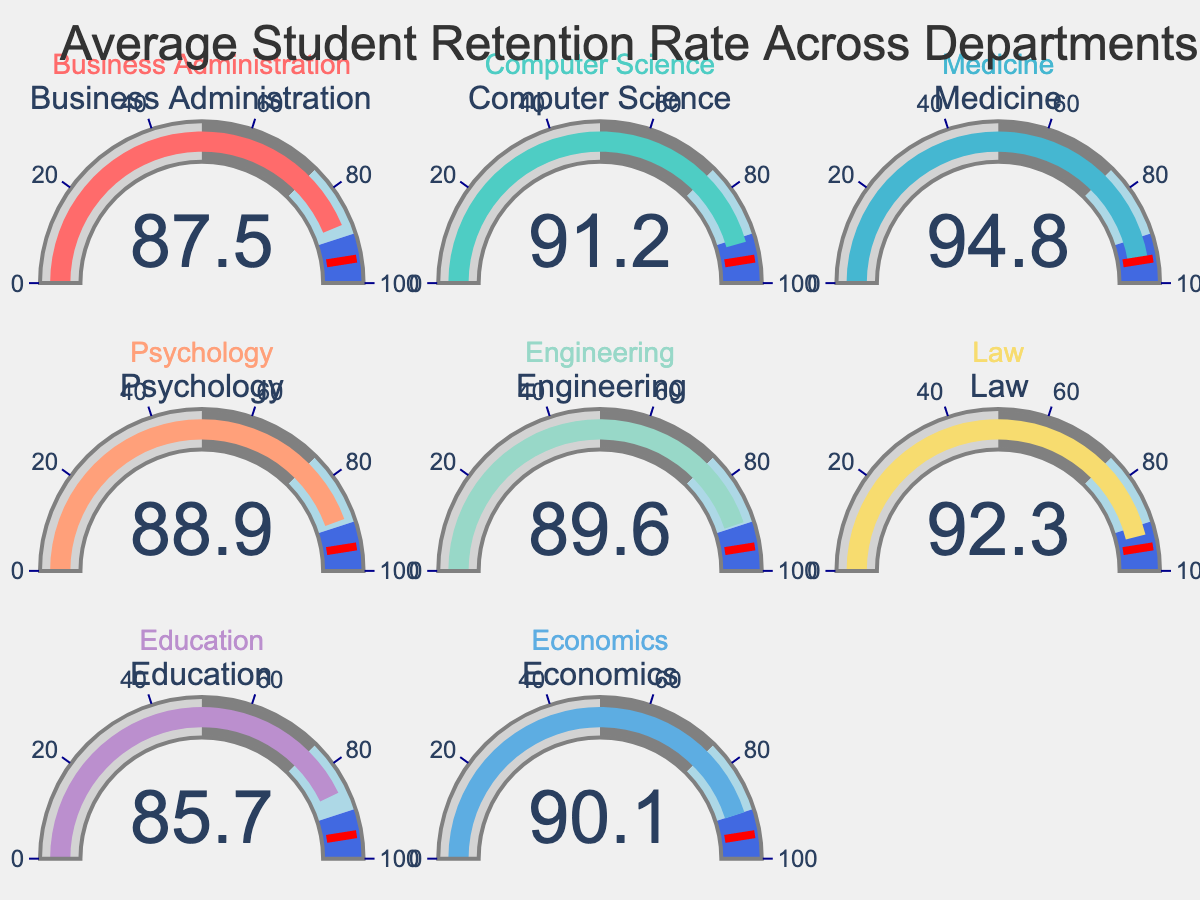How many departments are displayed in the figure? There are a total of eight departments shown in the gauge chart, each representing a different department in the dataset.
Answer: 8 Which department has the highest student retention rate? By examining the retention rates indicated on each gauge, Medicine has the highest retention rate at 94.8%.
Answer: Medicine Which department has the lowest student retention rate? By looking at the gauges, Education has the lowest retention rate at 85.7%.
Answer: Education What is the average student retention rate across all departments? To calculate the average, sum all the retention rates and divide by the number of departments. Sum = 87.5 + 91.2 + 94.8 + 88.9 + 89.6 + 92.3 + 85.7 + 90.1 = 720.1. Average = 720.1 / 8 = 90.0125%.
Answer: 90.01% Which departments have a retention rate higher than 90%? By examining each gauge, Computer Science (91.2%), Medicine (94.8%), Law (92.3%), and Economics (90.1%) all have retention rates higher than 90%.
Answer: Computer Science, Medicine, Law, Economics What is the difference between the highest and the lowest retention rates among the departments? The highest retention rate is 94.8% (Medicine) and the lowest is 85.7% (Education). The difference is 94.8 - 85.7 = 9.1%.
Answer: 9.1% How many departments have retention rates between 85% and 90%? Count the number of gauges with retention rates between 85% and 90%. These are Business Administration (87.5%), Psychology (88.9%), Engineering (89.6%), and Education (85.7%). There are four departments.
Answer: 4 Which departments fall below the threshold set at 95%? All departments have retention rates below the threshold of 95% as the highest rate is 94.8% in Medicine.
Answer: All departments What is the median retention rate of the departments? To find the median retention rate, first list the rates in ascending order: 85.7, 87.5, 88.9, 89.6, 90.1, 91.2, 92.3, 94.8. The median is the average of the 4th and 5th values: (89.6 + 90.1) / 2 = 89.85%.
Answer: 89.85% Which color is used to represent the Business Administration department? The gauge for Business Administration is displayed in the first color used, which is a shade of red (#FF6B6B).
Answer: Red 